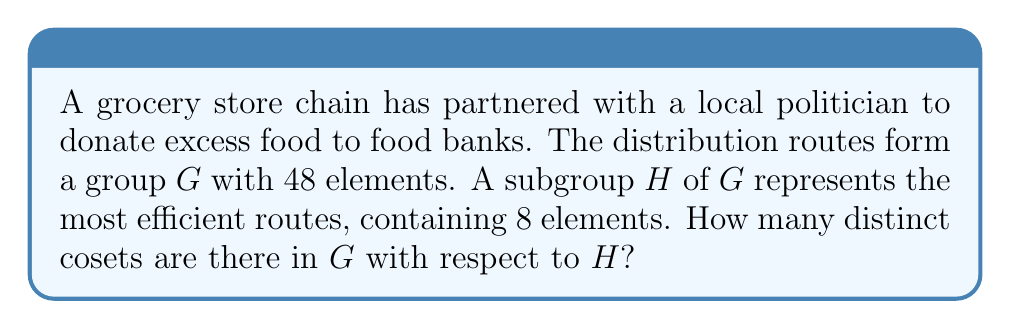Can you solve this math problem? To solve this problem, we'll use the following steps:

1) Recall Lagrange's Theorem: For a finite group $G$ and a subgroup $H$ of $G$, the order of $H$ divides the order of $G$. Moreover, the number of cosets of $H$ in $G$ is equal to the index of $H$ in $G$, denoted $[G:H]$.

2) The index $[G:H]$ is given by the formula:

   $$[G:H] = \frac{|G|}{|H|}$$

   where $|G|$ is the order of $G$ and $|H|$ is the order of $H$.

3) In this case:
   $|G| = 48$ (the total number of distribution routes)
   $|H| = 8$ (the number of most efficient routes)

4) Substituting these values into the formula:

   $$[G:H] = \frac{|G|}{|H|} = \frac{48}{8} = 6$$

5) Therefore, there are 6 distinct cosets of $H$ in $G$.

This means that the distribution routes can be divided into 6 distinct sets, each containing 8 routes. Each set represents a variation of the most efficient routes, potentially covering different areas or time slots for food distribution.
Answer: 6 cosets 